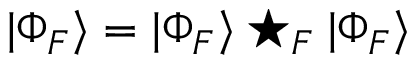<formula> <loc_0><loc_0><loc_500><loc_500>| \Phi _ { F } \rangle = | \Phi _ { F } \rangle ^ { * } _ { F } | \Phi _ { F } \rangle \,</formula> 